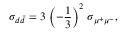Convert formula to latex. <formula><loc_0><loc_0><loc_500><loc_500>\sigma _ { d \bar { d } } = 3 \, \left ( - { \frac { 1 } { 3 } } \right ) ^ { 2 } \, \sigma _ { \mu ^ { + } \mu ^ { - } } ,</formula> 